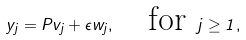<formula> <loc_0><loc_0><loc_500><loc_500>y _ { j } = P v _ { j } + \epsilon w _ { j } , \quad \text {for } j \geq 1 ,</formula> 